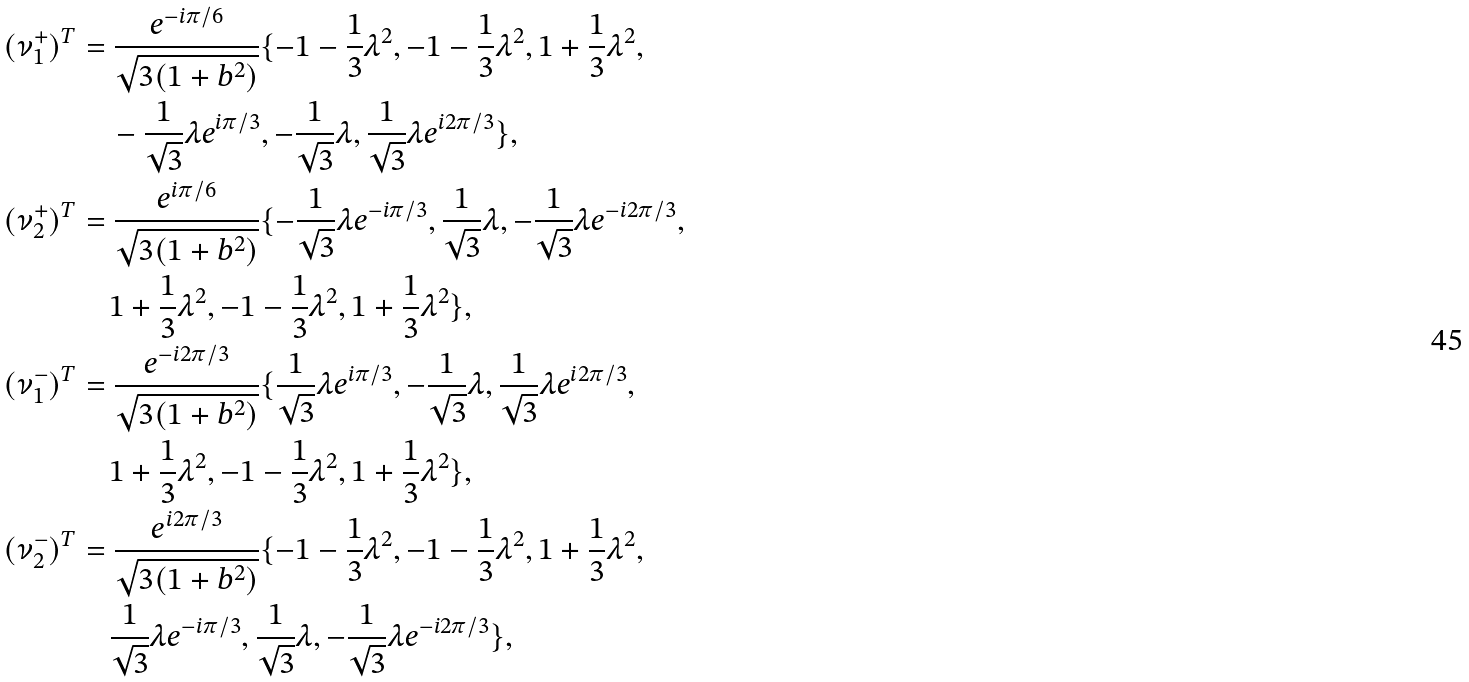<formula> <loc_0><loc_0><loc_500><loc_500>( \nu ^ { + } _ { 1 } ) ^ { T } & = \frac { e ^ { - i \pi / 6 } } { \sqrt { 3 ( 1 + b ^ { 2 } ) } } \{ - 1 - \frac { 1 } { 3 } \lambda ^ { 2 } , - 1 - \frac { 1 } { 3 } \lambda ^ { 2 } , 1 + \frac { 1 } { 3 } \lambda ^ { 2 } , \\ & \quad - \frac { 1 } { \sqrt { 3 } } \lambda e ^ { i \pi / 3 } , - \frac { 1 } { \sqrt { 3 } } \lambda , \frac { 1 } { \sqrt { 3 } } \lambda e ^ { i 2 \pi / 3 } \} , \\ ( \nu ^ { + } _ { 2 } ) ^ { T } & = \frac { e ^ { i \pi / 6 } } { \sqrt { 3 ( 1 + b ^ { 2 } ) } } \{ - \frac { 1 } { \sqrt { 3 } } \lambda e ^ { - i \pi / 3 } , \frac { 1 } { \sqrt { 3 } } \lambda , - \frac { 1 } { \sqrt { 3 } } \lambda e ^ { - i 2 \pi / 3 } , \\ & \quad 1 + \frac { 1 } { 3 } \lambda ^ { 2 } , - 1 - \frac { 1 } { 3 } \lambda ^ { 2 } , 1 + \frac { 1 } { 3 } \lambda ^ { 2 } \} , \\ ( \nu ^ { - } _ { 1 } ) ^ { T } & = \frac { e ^ { - i 2 \pi / 3 } } { \sqrt { 3 ( 1 + b ^ { 2 } ) } } \{ \frac { 1 } { \sqrt { 3 } } \lambda e ^ { i \pi / 3 } , - \frac { 1 } { \sqrt { 3 } } \lambda , \frac { 1 } { \sqrt { 3 } } \lambda e ^ { i 2 \pi / 3 } , \\ & \quad 1 + \frac { 1 } { 3 } \lambda ^ { 2 } , - 1 - \frac { 1 } { 3 } \lambda ^ { 2 } , 1 + \frac { 1 } { 3 } \lambda ^ { 2 } \} , \\ ( \nu ^ { - } _ { 2 } ) ^ { T } & = \frac { e ^ { i 2 \pi / 3 } } { \sqrt { 3 ( 1 + b ^ { 2 } ) } } \{ - 1 - \frac { 1 } { 3 } \lambda ^ { 2 } , - 1 - \frac { 1 } { 3 } \lambda ^ { 2 } , 1 + \frac { 1 } { 3 } \lambda ^ { 2 } , \\ & \quad \frac { 1 } { \sqrt { 3 } } \lambda e ^ { - i \pi / 3 } , \frac { 1 } { \sqrt { 3 } } \lambda , - \frac { 1 } { \sqrt { 3 } } \lambda e ^ { - i 2 \pi / 3 } \} ,</formula> 